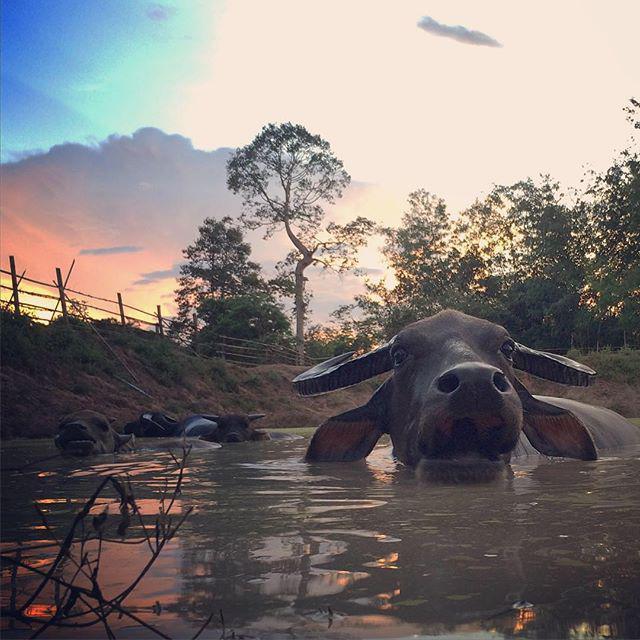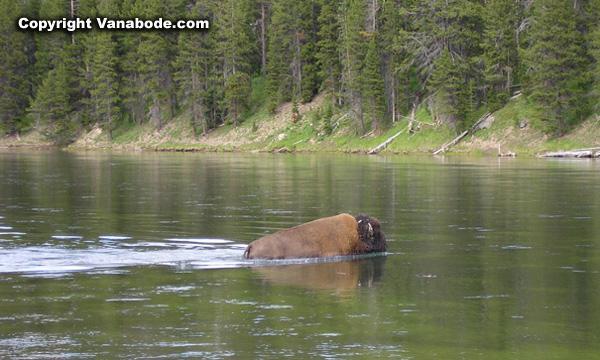The first image is the image on the left, the second image is the image on the right. Considering the images on both sides, is "A cow in the image on the left is walking through the water." valid? Answer yes or no. Yes. The first image is the image on the left, the second image is the image on the right. Evaluate the accuracy of this statement regarding the images: "In at least one image there is only a single bull up to its chest in water.". Is it true? Answer yes or no. Yes. 